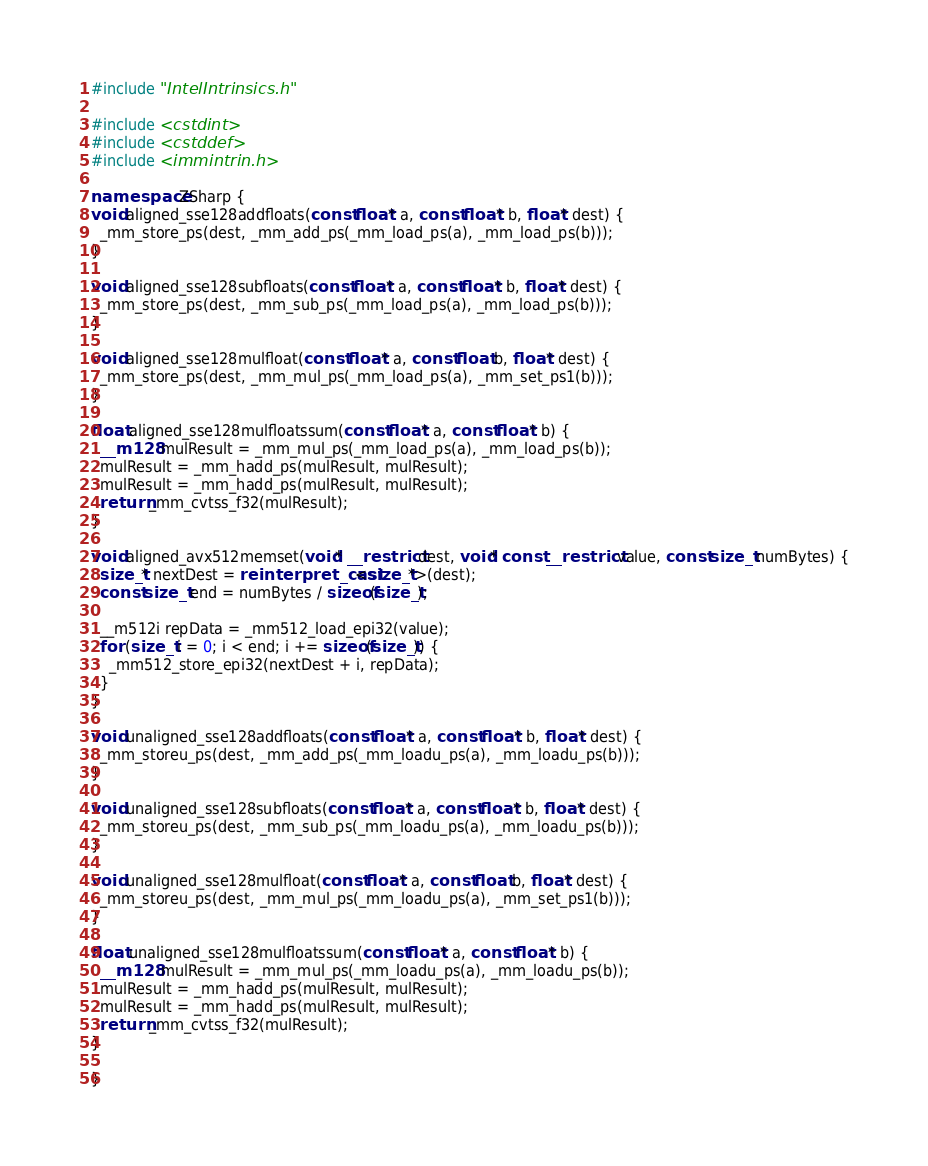Convert code to text. <code><loc_0><loc_0><loc_500><loc_500><_C++_>#include "IntelIntrinsics.h"

#include <cstdint>
#include <cstddef>
#include <immintrin.h>

namespace ZSharp {
void aligned_sse128addfloats(const float* a, const float* b, float* dest) {
  _mm_store_ps(dest, _mm_add_ps(_mm_load_ps(a), _mm_load_ps(b)));
}

void aligned_sse128subfloats(const float* a, const float* b, float* dest) {
  _mm_store_ps(dest, _mm_sub_ps(_mm_load_ps(a), _mm_load_ps(b)));
}

void aligned_sse128mulfloat(const float* a, const float b, float* dest) {
  _mm_store_ps(dest, _mm_mul_ps(_mm_load_ps(a), _mm_set_ps1(b)));
}

float aligned_sse128mulfloatssum(const float* a, const float* b) {
  __m128 mulResult = _mm_mul_ps(_mm_load_ps(a), _mm_load_ps(b));
  mulResult = _mm_hadd_ps(mulResult, mulResult);
  mulResult = _mm_hadd_ps(mulResult, mulResult);
  return _mm_cvtss_f32(mulResult);
}

void aligned_avx512memset(void* __restrict dest, void* const __restrict value, const size_t numBytes) {
  size_t* nextDest = reinterpret_cast<size_t*>(dest);
  const size_t end = numBytes / sizeof(size_t);

  __m512i repData = _mm512_load_epi32(value);
  for (size_t i = 0; i < end; i += sizeof(size_t)) {
    _mm512_store_epi32(nextDest + i, repData);
  }
}

void unaligned_sse128addfloats(const float* a, const float* b, float* dest) {
  _mm_storeu_ps(dest, _mm_add_ps(_mm_loadu_ps(a), _mm_loadu_ps(b)));
}

void unaligned_sse128subfloats(const float* a, const float* b, float* dest) {
  _mm_storeu_ps(dest, _mm_sub_ps(_mm_loadu_ps(a), _mm_loadu_ps(b)));
}

void unaligned_sse128mulfloat(const float* a, const float b, float* dest) {
  _mm_storeu_ps(dest, _mm_mul_ps(_mm_loadu_ps(a), _mm_set_ps1(b)));
}

float unaligned_sse128mulfloatssum(const float* a, const float* b) {
  __m128 mulResult = _mm_mul_ps(_mm_loadu_ps(a), _mm_loadu_ps(b));
  mulResult = _mm_hadd_ps(mulResult, mulResult);
  mulResult = _mm_hadd_ps(mulResult, mulResult);
  return _mm_cvtss_f32(mulResult);
}

}
</code> 